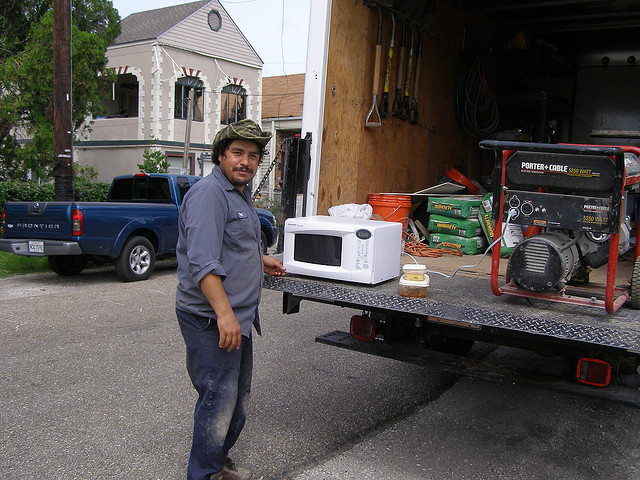Read and extract the text from this image. PORTER CABLE nnoNTIOR 